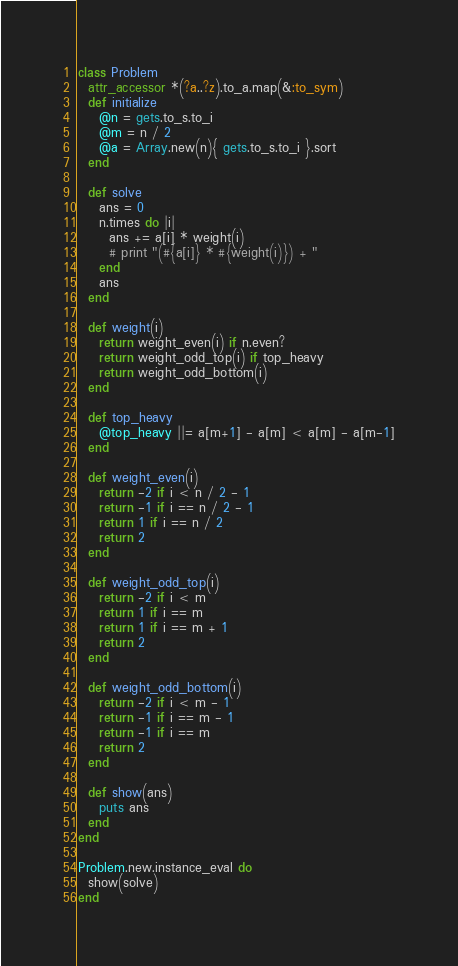Convert code to text. <code><loc_0><loc_0><loc_500><loc_500><_Ruby_>class Problem
  attr_accessor *(?a..?z).to_a.map(&:to_sym)
  def initialize
    @n = gets.to_s.to_i
    @m = n / 2
    @a = Array.new(n){ gets.to_s.to_i }.sort
  end
  
  def solve
    ans = 0
    n.times do |i|
      ans += a[i] * weight(i)
      # print "(#{a[i]} * #{weight(i)}) + "
    end
    ans
  end
  
  def weight(i)
    return weight_even(i) if n.even?
    return weight_odd_top(i) if top_heavy
    return weight_odd_bottom(i)
  end

  def top_heavy
    @top_heavy ||= a[m+1] - a[m] < a[m] - a[m-1]
  end
    
  def weight_even(i)
    return -2 if i < n / 2 - 1
    return -1 if i == n / 2 - 1
    return 1 if i == n / 2
    return 2
  end
  
  def weight_odd_top(i)
    return -2 if i < m
    return 1 if i == m
    return 1 if i == m + 1
    return 2
  end
  
  def weight_odd_bottom(i)
    return -2 if i < m - 1
    return -1 if i == m - 1
    return -1 if i == m
    return 2
  end

  def show(ans)
    puts ans
  end
end

Problem.new.instance_eval do
  show(solve)
end</code> 